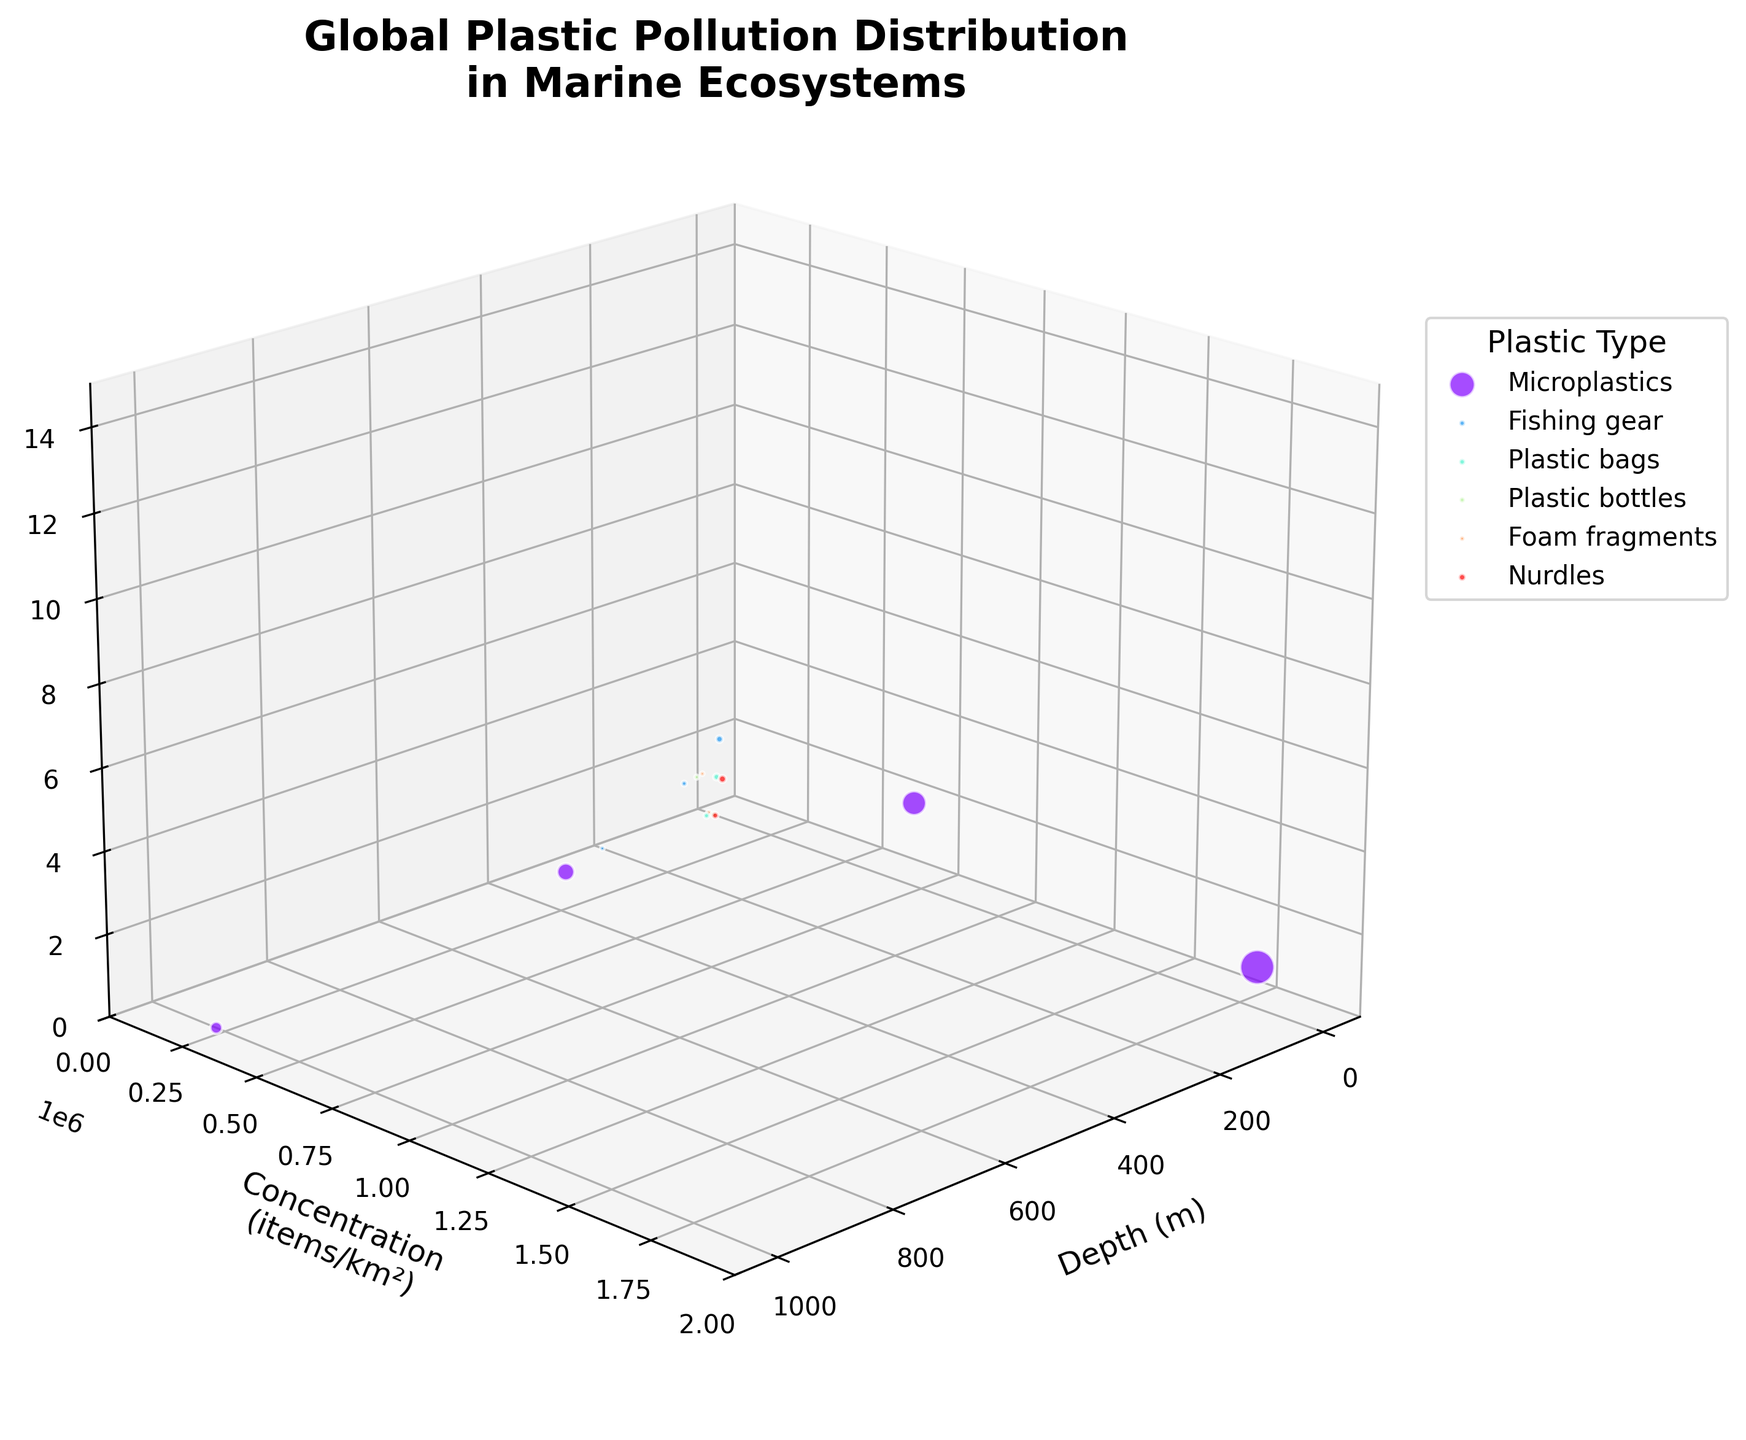What is the title of the 3D plot? The title is displayed at the top of the figure and provides an overview of what the plot represents. The title here is "Global Plastic Pollution Distribution in Marine Ecosystems."
Answer: Global Plastic Pollution Distribution in Marine Ecosystems Which type of plastic has the highest concentration at the surface level? By looking at the plot, you can identify the data points at depth 0. Among these points, "Microplastics" have the highest concentration.
Answer: Microplastics What is the average concentration of microplastics across all depths? To find this, add the concentrations of microplastics across all depths and divide by the number of depths. (1800000 + 890000 + 450000 + 220000) / 4 = 3360000 / 4
Answer: 840000 How does the concentration of plastic bags in the Caribbean Sea compare to the concentration of fishing gear in the South China Sea? Look at the respective data points for plastic bags in the Caribbean Sea (65000) and fishing gear in the South China Sea (75000). Compare these values.
Answer: Fishing gear in the South China Sea has a higher concentration (75000 vs. 65000) Which location has the highest concentration of nurdles? Examine the data points for nurdles and compare their concentrations. The Yellow Sea has the highest concentration (85000) compared to the Sargasso Sea (62000).
Answer: Yellow Sea What is the median depth of plastic bottles in the dataset? Identify the depths for plastic bottles (0 and 20 meters). The median depth is the middle value when they are ordered, so (0 + 20) / 2 = 10 meters.
Answer: 10 meters Which type of plastic is predominant in shallow waters (less than 10 meters)? Observe the types of plastics at depths less than 10 meters (including depth 0). Microplastics are predominant with a significantly higher concentration compared to others.
Answer: Microplastics How many different types of plastics are included in the plot? Count the unique plastic types represented in the legend or the plot itself. The different types are "Microplastics," "Fishing gear," "Plastic bags," "Plastic bottles," "Foam fragments," and "Nurdles."
Answer: 6 What is the range of concentrations for plastic bags across all measured depths and locations? Identify the minimum and maximum concentrations of plastic bags. The minimum concentration is 48000 and the maximum is 65000. The range is 65000 - 48000 = 17000 items/km².
Answer: 17000 items/km² 